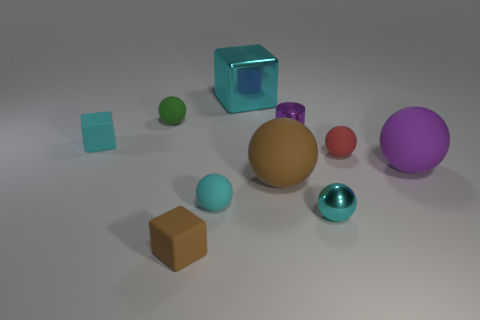Subtract 4 spheres. How many spheres are left? 2 Subtract all small red matte spheres. How many spheres are left? 5 Subtract all cyan balls. How many balls are left? 4 Subtract all blue spheres. Subtract all yellow cylinders. How many spheres are left? 6 Subtract all blocks. How many objects are left? 7 Add 6 green balls. How many green balls are left? 7 Add 7 big yellow blocks. How many big yellow blocks exist? 7 Subtract 1 purple cylinders. How many objects are left? 9 Subtract all red cubes. Subtract all tiny green rubber objects. How many objects are left? 9 